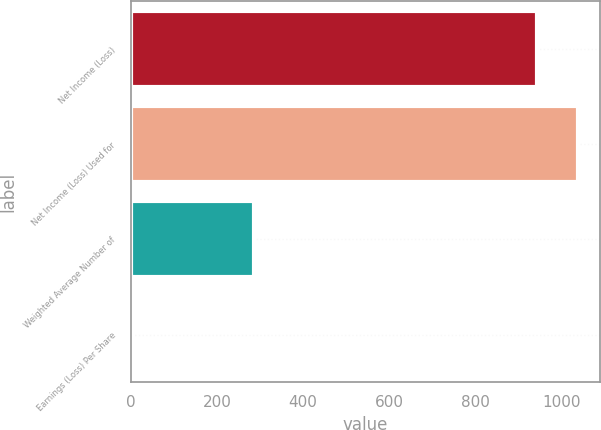Convert chart. <chart><loc_0><loc_0><loc_500><loc_500><bar_chart><fcel>Net Income (Loss)<fcel>Net Income (Loss) Used for<fcel>Weighted Average Number of<fcel>Earnings (Loss) Per Share<nl><fcel>944<fcel>1037.86<fcel>287.02<fcel>5.45<nl></chart> 